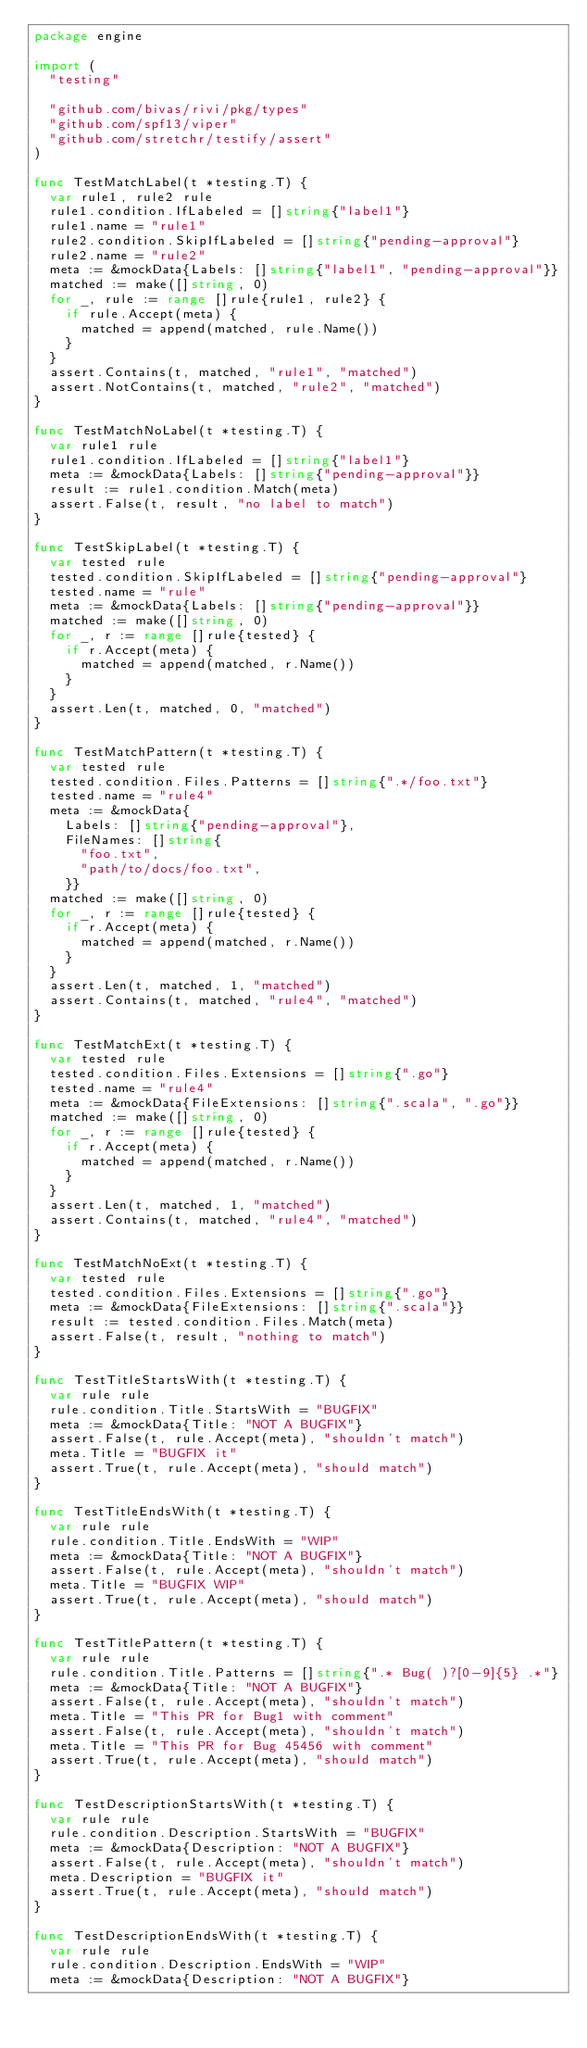Convert code to text. <code><loc_0><loc_0><loc_500><loc_500><_Go_>package engine

import (
	"testing"

	"github.com/bivas/rivi/pkg/types"
	"github.com/spf13/viper"
	"github.com/stretchr/testify/assert"
)

func TestMatchLabel(t *testing.T) {
	var rule1, rule2 rule
	rule1.condition.IfLabeled = []string{"label1"}
	rule1.name = "rule1"
	rule2.condition.SkipIfLabeled = []string{"pending-approval"}
	rule2.name = "rule2"
	meta := &mockData{Labels: []string{"label1", "pending-approval"}}
	matched := make([]string, 0)
	for _, rule := range []rule{rule1, rule2} {
		if rule.Accept(meta) {
			matched = append(matched, rule.Name())
		}
	}
	assert.Contains(t, matched, "rule1", "matched")
	assert.NotContains(t, matched, "rule2", "matched")
}

func TestMatchNoLabel(t *testing.T) {
	var rule1 rule
	rule1.condition.IfLabeled = []string{"label1"}
	meta := &mockData{Labels: []string{"pending-approval"}}
	result := rule1.condition.Match(meta)
	assert.False(t, result, "no label to match")
}

func TestSkipLabel(t *testing.T) {
	var tested rule
	tested.condition.SkipIfLabeled = []string{"pending-approval"}
	tested.name = "rule"
	meta := &mockData{Labels: []string{"pending-approval"}}
	matched := make([]string, 0)
	for _, r := range []rule{tested} {
		if r.Accept(meta) {
			matched = append(matched, r.Name())
		}
	}
	assert.Len(t, matched, 0, "matched")
}

func TestMatchPattern(t *testing.T) {
	var tested rule
	tested.condition.Files.Patterns = []string{".*/foo.txt"}
	tested.name = "rule4"
	meta := &mockData{
		Labels: []string{"pending-approval"},
		FileNames: []string{
			"foo.txt",
			"path/to/docs/foo.txt",
		}}
	matched := make([]string, 0)
	for _, r := range []rule{tested} {
		if r.Accept(meta) {
			matched = append(matched, r.Name())
		}
	}
	assert.Len(t, matched, 1, "matched")
	assert.Contains(t, matched, "rule4", "matched")
}

func TestMatchExt(t *testing.T) {
	var tested rule
	tested.condition.Files.Extensions = []string{".go"}
	tested.name = "rule4"
	meta := &mockData{FileExtensions: []string{".scala", ".go"}}
	matched := make([]string, 0)
	for _, r := range []rule{tested} {
		if r.Accept(meta) {
			matched = append(matched, r.Name())
		}
	}
	assert.Len(t, matched, 1, "matched")
	assert.Contains(t, matched, "rule4", "matched")
}

func TestMatchNoExt(t *testing.T) {
	var tested rule
	tested.condition.Files.Extensions = []string{".go"}
	meta := &mockData{FileExtensions: []string{".scala"}}
	result := tested.condition.Files.Match(meta)
	assert.False(t, result, "nothing to match")
}

func TestTitleStartsWith(t *testing.T) {
	var rule rule
	rule.condition.Title.StartsWith = "BUGFIX"
	meta := &mockData{Title: "NOT A BUGFIX"}
	assert.False(t, rule.Accept(meta), "shouldn't match")
	meta.Title = "BUGFIX it"
	assert.True(t, rule.Accept(meta), "should match")
}

func TestTitleEndsWith(t *testing.T) {
	var rule rule
	rule.condition.Title.EndsWith = "WIP"
	meta := &mockData{Title: "NOT A BUGFIX"}
	assert.False(t, rule.Accept(meta), "shouldn't match")
	meta.Title = "BUGFIX WIP"
	assert.True(t, rule.Accept(meta), "should match")
}

func TestTitlePattern(t *testing.T) {
	var rule rule
	rule.condition.Title.Patterns = []string{".* Bug( )?[0-9]{5} .*"}
	meta := &mockData{Title: "NOT A BUGFIX"}
	assert.False(t, rule.Accept(meta), "shouldn't match")
	meta.Title = "This PR for Bug1 with comment"
	assert.False(t, rule.Accept(meta), "shouldn't match")
	meta.Title = "This PR for Bug 45456 with comment"
	assert.True(t, rule.Accept(meta), "should match")
}

func TestDescriptionStartsWith(t *testing.T) {
	var rule rule
	rule.condition.Description.StartsWith = "BUGFIX"
	meta := &mockData{Description: "NOT A BUGFIX"}
	assert.False(t, rule.Accept(meta), "shouldn't match")
	meta.Description = "BUGFIX it"
	assert.True(t, rule.Accept(meta), "should match")
}

func TestDescriptionEndsWith(t *testing.T) {
	var rule rule
	rule.condition.Description.EndsWith = "WIP"
	meta := &mockData{Description: "NOT A BUGFIX"}</code> 